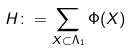Convert formula to latex. <formula><loc_0><loc_0><loc_500><loc_500>H \colon = \sum _ { X \subset \Lambda _ { 1 } } \Phi ( X )</formula> 